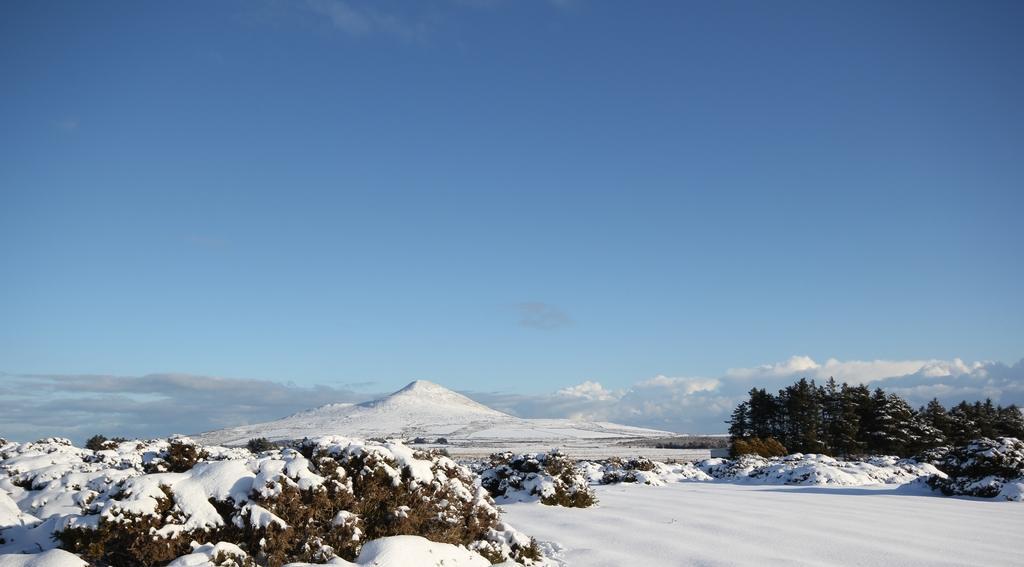Could you give a brief overview of what you see in this image? In this picture I can see snow. I can see trees. I can see clouds in the sky. 